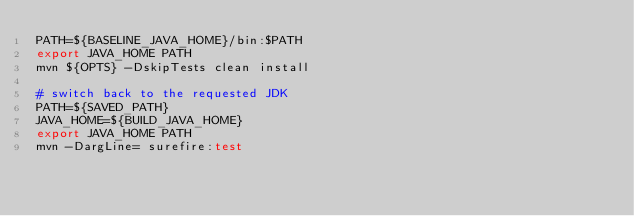<code> <loc_0><loc_0><loc_500><loc_500><_Bash_>PATH=${BASELINE_JAVA_HOME}/bin:$PATH
export JAVA_HOME PATH
mvn ${OPTS} -DskipTests clean install

# switch back to the requested JDK
PATH=${SAVED_PATH}
JAVA_HOME=${BUILD_JAVA_HOME}
export JAVA_HOME PATH
mvn -DargLine= surefire:test</code> 